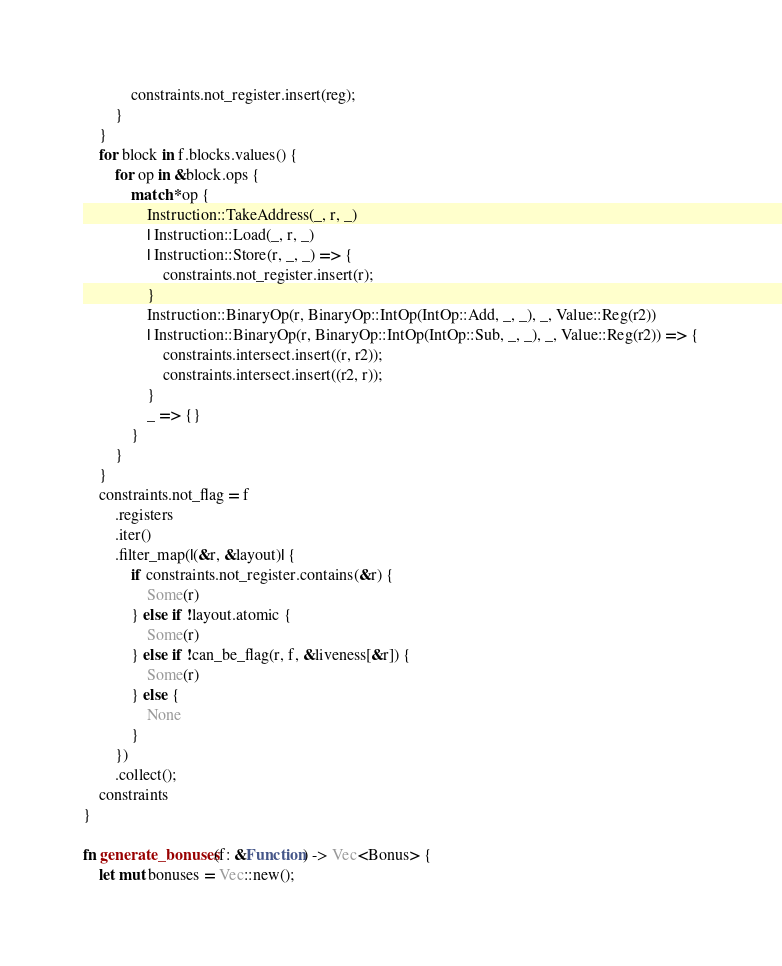Convert code to text. <code><loc_0><loc_0><loc_500><loc_500><_Rust_>            constraints.not_register.insert(reg);
        }
    }
    for block in f.blocks.values() {
        for op in &block.ops {
            match *op {
                Instruction::TakeAddress(_, r, _)
                | Instruction::Load(_, r, _)
                | Instruction::Store(r, _, _) => {
                    constraints.not_register.insert(r);
                }
                Instruction::BinaryOp(r, BinaryOp::IntOp(IntOp::Add, _, _), _, Value::Reg(r2))
                | Instruction::BinaryOp(r, BinaryOp::IntOp(IntOp::Sub, _, _), _, Value::Reg(r2)) => {
                    constraints.intersect.insert((r, r2));
                    constraints.intersect.insert((r2, r));
                }
                _ => {}
            }
        }
    }
    constraints.not_flag = f
        .registers
        .iter()
        .filter_map(|(&r, &layout)| {
            if constraints.not_register.contains(&r) {
                Some(r)
            } else if !layout.atomic {
                Some(r)
            } else if !can_be_flag(r, f, &liveness[&r]) {
                Some(r)
            } else {
                None
            }
        })
        .collect();
    constraints
}

fn generate_bonuses(f: &Function) -> Vec<Bonus> {
    let mut bonuses = Vec::new();</code> 